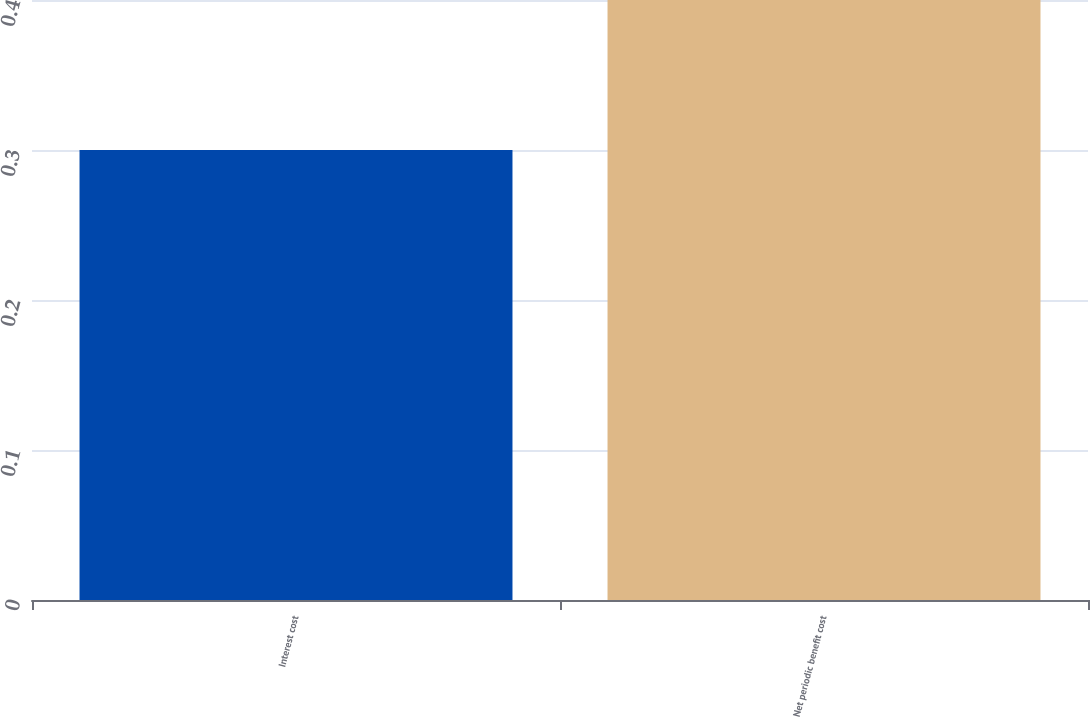Convert chart. <chart><loc_0><loc_0><loc_500><loc_500><bar_chart><fcel>Interest cost<fcel>Net periodic benefit cost<nl><fcel>0.3<fcel>0.4<nl></chart> 